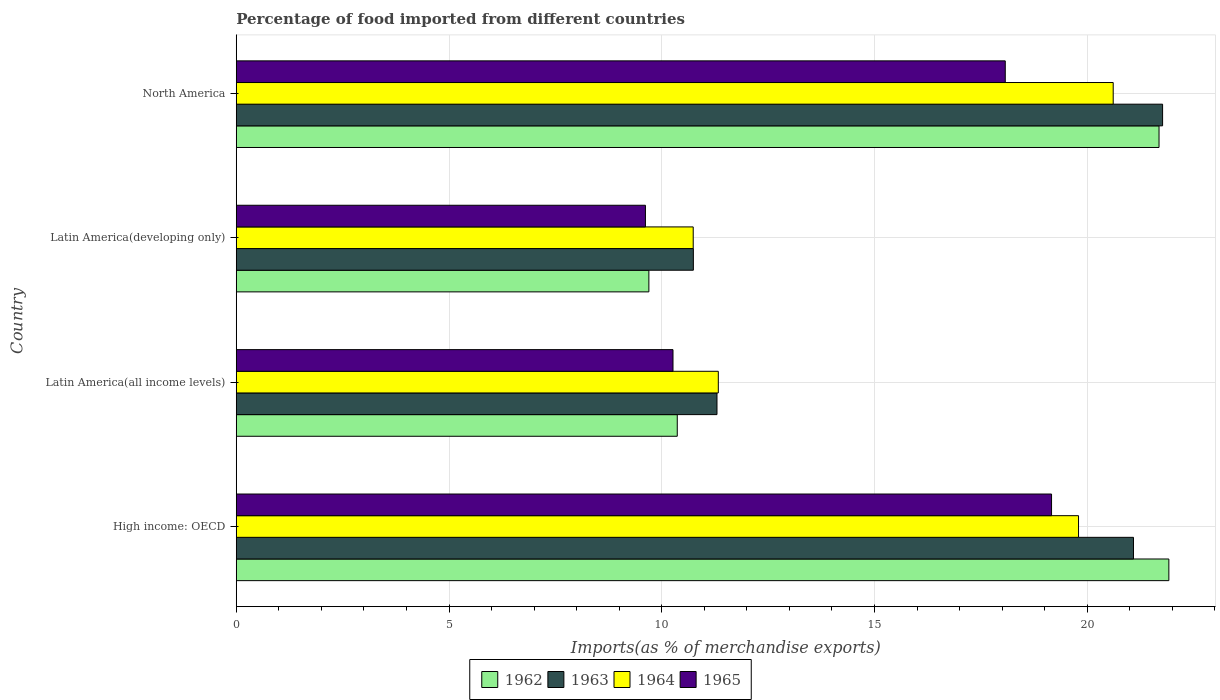What is the label of the 1st group of bars from the top?
Provide a succinct answer. North America. What is the percentage of imports to different countries in 1963 in North America?
Give a very brief answer. 21.77. Across all countries, what is the maximum percentage of imports to different countries in 1962?
Keep it short and to the point. 21.92. Across all countries, what is the minimum percentage of imports to different countries in 1962?
Provide a succinct answer. 9.7. In which country was the percentage of imports to different countries in 1962 maximum?
Your answer should be compact. High income: OECD. In which country was the percentage of imports to different countries in 1963 minimum?
Your answer should be compact. Latin America(developing only). What is the total percentage of imports to different countries in 1964 in the graph?
Provide a succinct answer. 62.47. What is the difference between the percentage of imports to different countries in 1963 in High income: OECD and that in Latin America(developing only)?
Your response must be concise. 10.34. What is the difference between the percentage of imports to different countries in 1962 in Latin America(all income levels) and the percentage of imports to different countries in 1963 in North America?
Give a very brief answer. -11.41. What is the average percentage of imports to different countries in 1965 per country?
Keep it short and to the point. 14.28. What is the difference between the percentage of imports to different countries in 1964 and percentage of imports to different countries in 1965 in Latin America(all income levels)?
Make the answer very short. 1.07. What is the ratio of the percentage of imports to different countries in 1962 in High income: OECD to that in Latin America(all income levels)?
Your answer should be compact. 2.11. Is the percentage of imports to different countries in 1965 in Latin America(all income levels) less than that in North America?
Make the answer very short. Yes. Is the difference between the percentage of imports to different countries in 1964 in High income: OECD and Latin America(developing only) greater than the difference between the percentage of imports to different countries in 1965 in High income: OECD and Latin America(developing only)?
Give a very brief answer. No. What is the difference between the highest and the second highest percentage of imports to different countries in 1963?
Make the answer very short. 0.68. What is the difference between the highest and the lowest percentage of imports to different countries in 1962?
Your answer should be compact. 12.22. Is the sum of the percentage of imports to different countries in 1962 in Latin America(all income levels) and Latin America(developing only) greater than the maximum percentage of imports to different countries in 1965 across all countries?
Ensure brevity in your answer.  Yes. What does the 4th bar from the top in Latin America(developing only) represents?
Make the answer very short. 1962. Is it the case that in every country, the sum of the percentage of imports to different countries in 1963 and percentage of imports to different countries in 1962 is greater than the percentage of imports to different countries in 1965?
Ensure brevity in your answer.  Yes. How many countries are there in the graph?
Offer a very short reply. 4. What is the difference between two consecutive major ticks on the X-axis?
Make the answer very short. 5. Does the graph contain grids?
Your response must be concise. Yes. Where does the legend appear in the graph?
Offer a terse response. Bottom center. How are the legend labels stacked?
Provide a succinct answer. Horizontal. What is the title of the graph?
Your response must be concise. Percentage of food imported from different countries. Does "2003" appear as one of the legend labels in the graph?
Ensure brevity in your answer.  No. What is the label or title of the X-axis?
Your answer should be compact. Imports(as % of merchandise exports). What is the Imports(as % of merchandise exports) of 1962 in High income: OECD?
Your answer should be very brief. 21.92. What is the Imports(as % of merchandise exports) in 1963 in High income: OECD?
Ensure brevity in your answer.  21.09. What is the Imports(as % of merchandise exports) of 1964 in High income: OECD?
Keep it short and to the point. 19.8. What is the Imports(as % of merchandise exports) of 1965 in High income: OECD?
Provide a succinct answer. 19.16. What is the Imports(as % of merchandise exports) of 1962 in Latin America(all income levels)?
Give a very brief answer. 10.36. What is the Imports(as % of merchandise exports) in 1963 in Latin America(all income levels)?
Your answer should be very brief. 11.3. What is the Imports(as % of merchandise exports) of 1964 in Latin America(all income levels)?
Provide a short and direct response. 11.33. What is the Imports(as % of merchandise exports) of 1965 in Latin America(all income levels)?
Provide a succinct answer. 10.26. What is the Imports(as % of merchandise exports) of 1962 in Latin America(developing only)?
Your response must be concise. 9.7. What is the Imports(as % of merchandise exports) in 1963 in Latin America(developing only)?
Keep it short and to the point. 10.74. What is the Imports(as % of merchandise exports) of 1964 in Latin America(developing only)?
Provide a succinct answer. 10.74. What is the Imports(as % of merchandise exports) in 1965 in Latin America(developing only)?
Ensure brevity in your answer.  9.62. What is the Imports(as % of merchandise exports) of 1962 in North America?
Ensure brevity in your answer.  21.69. What is the Imports(as % of merchandise exports) in 1963 in North America?
Your answer should be very brief. 21.77. What is the Imports(as % of merchandise exports) of 1964 in North America?
Offer a terse response. 20.61. What is the Imports(as % of merchandise exports) of 1965 in North America?
Offer a terse response. 18.07. Across all countries, what is the maximum Imports(as % of merchandise exports) of 1962?
Provide a succinct answer. 21.92. Across all countries, what is the maximum Imports(as % of merchandise exports) of 1963?
Offer a terse response. 21.77. Across all countries, what is the maximum Imports(as % of merchandise exports) in 1964?
Your answer should be very brief. 20.61. Across all countries, what is the maximum Imports(as % of merchandise exports) of 1965?
Keep it short and to the point. 19.16. Across all countries, what is the minimum Imports(as % of merchandise exports) in 1962?
Make the answer very short. 9.7. Across all countries, what is the minimum Imports(as % of merchandise exports) in 1963?
Offer a terse response. 10.74. Across all countries, what is the minimum Imports(as % of merchandise exports) of 1964?
Make the answer very short. 10.74. Across all countries, what is the minimum Imports(as % of merchandise exports) in 1965?
Your response must be concise. 9.62. What is the total Imports(as % of merchandise exports) of 1962 in the graph?
Give a very brief answer. 63.67. What is the total Imports(as % of merchandise exports) of 1963 in the graph?
Offer a very short reply. 64.9. What is the total Imports(as % of merchandise exports) in 1964 in the graph?
Your answer should be compact. 62.48. What is the total Imports(as % of merchandise exports) in 1965 in the graph?
Ensure brevity in your answer.  57.12. What is the difference between the Imports(as % of merchandise exports) of 1962 in High income: OECD and that in Latin America(all income levels)?
Offer a very short reply. 11.55. What is the difference between the Imports(as % of merchandise exports) of 1963 in High income: OECD and that in Latin America(all income levels)?
Ensure brevity in your answer.  9.79. What is the difference between the Imports(as % of merchandise exports) in 1964 in High income: OECD and that in Latin America(all income levels)?
Your answer should be very brief. 8.47. What is the difference between the Imports(as % of merchandise exports) of 1965 in High income: OECD and that in Latin America(all income levels)?
Your answer should be very brief. 8.9. What is the difference between the Imports(as % of merchandise exports) of 1962 in High income: OECD and that in Latin America(developing only)?
Offer a very short reply. 12.22. What is the difference between the Imports(as % of merchandise exports) of 1963 in High income: OECD and that in Latin America(developing only)?
Make the answer very short. 10.34. What is the difference between the Imports(as % of merchandise exports) in 1964 in High income: OECD and that in Latin America(developing only)?
Provide a short and direct response. 9.06. What is the difference between the Imports(as % of merchandise exports) in 1965 in High income: OECD and that in Latin America(developing only)?
Your answer should be compact. 9.54. What is the difference between the Imports(as % of merchandise exports) of 1962 in High income: OECD and that in North America?
Provide a short and direct response. 0.23. What is the difference between the Imports(as % of merchandise exports) in 1963 in High income: OECD and that in North America?
Your answer should be compact. -0.68. What is the difference between the Imports(as % of merchandise exports) in 1964 in High income: OECD and that in North America?
Keep it short and to the point. -0.81. What is the difference between the Imports(as % of merchandise exports) of 1965 in High income: OECD and that in North America?
Offer a terse response. 1.09. What is the difference between the Imports(as % of merchandise exports) of 1962 in Latin America(all income levels) and that in Latin America(developing only)?
Offer a terse response. 0.67. What is the difference between the Imports(as % of merchandise exports) in 1963 in Latin America(all income levels) and that in Latin America(developing only)?
Your answer should be very brief. 0.56. What is the difference between the Imports(as % of merchandise exports) of 1964 in Latin America(all income levels) and that in Latin America(developing only)?
Give a very brief answer. 0.59. What is the difference between the Imports(as % of merchandise exports) in 1965 in Latin America(all income levels) and that in Latin America(developing only)?
Ensure brevity in your answer.  0.65. What is the difference between the Imports(as % of merchandise exports) in 1962 in Latin America(all income levels) and that in North America?
Your answer should be very brief. -11.32. What is the difference between the Imports(as % of merchandise exports) in 1963 in Latin America(all income levels) and that in North America?
Your response must be concise. -10.47. What is the difference between the Imports(as % of merchandise exports) in 1964 in Latin America(all income levels) and that in North America?
Give a very brief answer. -9.28. What is the difference between the Imports(as % of merchandise exports) of 1965 in Latin America(all income levels) and that in North America?
Your answer should be compact. -7.81. What is the difference between the Imports(as % of merchandise exports) in 1962 in Latin America(developing only) and that in North America?
Provide a short and direct response. -11.99. What is the difference between the Imports(as % of merchandise exports) of 1963 in Latin America(developing only) and that in North America?
Provide a succinct answer. -11.03. What is the difference between the Imports(as % of merchandise exports) of 1964 in Latin America(developing only) and that in North America?
Your response must be concise. -9.87. What is the difference between the Imports(as % of merchandise exports) in 1965 in Latin America(developing only) and that in North America?
Make the answer very short. -8.46. What is the difference between the Imports(as % of merchandise exports) of 1962 in High income: OECD and the Imports(as % of merchandise exports) of 1963 in Latin America(all income levels)?
Provide a short and direct response. 10.62. What is the difference between the Imports(as % of merchandise exports) of 1962 in High income: OECD and the Imports(as % of merchandise exports) of 1964 in Latin America(all income levels)?
Your answer should be compact. 10.59. What is the difference between the Imports(as % of merchandise exports) of 1962 in High income: OECD and the Imports(as % of merchandise exports) of 1965 in Latin America(all income levels)?
Offer a very short reply. 11.65. What is the difference between the Imports(as % of merchandise exports) in 1963 in High income: OECD and the Imports(as % of merchandise exports) in 1964 in Latin America(all income levels)?
Offer a very short reply. 9.76. What is the difference between the Imports(as % of merchandise exports) in 1963 in High income: OECD and the Imports(as % of merchandise exports) in 1965 in Latin America(all income levels)?
Provide a short and direct response. 10.82. What is the difference between the Imports(as % of merchandise exports) of 1964 in High income: OECD and the Imports(as % of merchandise exports) of 1965 in Latin America(all income levels)?
Your answer should be very brief. 9.53. What is the difference between the Imports(as % of merchandise exports) in 1962 in High income: OECD and the Imports(as % of merchandise exports) in 1963 in Latin America(developing only)?
Your answer should be very brief. 11.18. What is the difference between the Imports(as % of merchandise exports) in 1962 in High income: OECD and the Imports(as % of merchandise exports) in 1964 in Latin America(developing only)?
Offer a terse response. 11.18. What is the difference between the Imports(as % of merchandise exports) in 1962 in High income: OECD and the Imports(as % of merchandise exports) in 1965 in Latin America(developing only)?
Keep it short and to the point. 12.3. What is the difference between the Imports(as % of merchandise exports) of 1963 in High income: OECD and the Imports(as % of merchandise exports) of 1964 in Latin America(developing only)?
Provide a short and direct response. 10.35. What is the difference between the Imports(as % of merchandise exports) of 1963 in High income: OECD and the Imports(as % of merchandise exports) of 1965 in Latin America(developing only)?
Your response must be concise. 11.47. What is the difference between the Imports(as % of merchandise exports) in 1964 in High income: OECD and the Imports(as % of merchandise exports) in 1965 in Latin America(developing only)?
Give a very brief answer. 10.18. What is the difference between the Imports(as % of merchandise exports) in 1962 in High income: OECD and the Imports(as % of merchandise exports) in 1963 in North America?
Offer a very short reply. 0.15. What is the difference between the Imports(as % of merchandise exports) in 1962 in High income: OECD and the Imports(as % of merchandise exports) in 1964 in North America?
Ensure brevity in your answer.  1.31. What is the difference between the Imports(as % of merchandise exports) of 1962 in High income: OECD and the Imports(as % of merchandise exports) of 1965 in North America?
Offer a terse response. 3.84. What is the difference between the Imports(as % of merchandise exports) of 1963 in High income: OECD and the Imports(as % of merchandise exports) of 1964 in North America?
Your answer should be very brief. 0.48. What is the difference between the Imports(as % of merchandise exports) in 1963 in High income: OECD and the Imports(as % of merchandise exports) in 1965 in North America?
Your answer should be compact. 3.01. What is the difference between the Imports(as % of merchandise exports) in 1964 in High income: OECD and the Imports(as % of merchandise exports) in 1965 in North America?
Provide a short and direct response. 1.72. What is the difference between the Imports(as % of merchandise exports) of 1962 in Latin America(all income levels) and the Imports(as % of merchandise exports) of 1963 in Latin America(developing only)?
Your answer should be compact. -0.38. What is the difference between the Imports(as % of merchandise exports) of 1962 in Latin America(all income levels) and the Imports(as % of merchandise exports) of 1964 in Latin America(developing only)?
Offer a very short reply. -0.37. What is the difference between the Imports(as % of merchandise exports) in 1962 in Latin America(all income levels) and the Imports(as % of merchandise exports) in 1965 in Latin America(developing only)?
Provide a short and direct response. 0.75. What is the difference between the Imports(as % of merchandise exports) of 1963 in Latin America(all income levels) and the Imports(as % of merchandise exports) of 1964 in Latin America(developing only)?
Provide a succinct answer. 0.56. What is the difference between the Imports(as % of merchandise exports) of 1963 in Latin America(all income levels) and the Imports(as % of merchandise exports) of 1965 in Latin America(developing only)?
Keep it short and to the point. 1.68. What is the difference between the Imports(as % of merchandise exports) of 1964 in Latin America(all income levels) and the Imports(as % of merchandise exports) of 1965 in Latin America(developing only)?
Your answer should be very brief. 1.71. What is the difference between the Imports(as % of merchandise exports) in 1962 in Latin America(all income levels) and the Imports(as % of merchandise exports) in 1963 in North America?
Your response must be concise. -11.41. What is the difference between the Imports(as % of merchandise exports) of 1962 in Latin America(all income levels) and the Imports(as % of merchandise exports) of 1964 in North America?
Offer a terse response. -10.25. What is the difference between the Imports(as % of merchandise exports) in 1962 in Latin America(all income levels) and the Imports(as % of merchandise exports) in 1965 in North America?
Offer a terse response. -7.71. What is the difference between the Imports(as % of merchandise exports) of 1963 in Latin America(all income levels) and the Imports(as % of merchandise exports) of 1964 in North America?
Provide a succinct answer. -9.31. What is the difference between the Imports(as % of merchandise exports) in 1963 in Latin America(all income levels) and the Imports(as % of merchandise exports) in 1965 in North America?
Provide a short and direct response. -6.78. What is the difference between the Imports(as % of merchandise exports) of 1964 in Latin America(all income levels) and the Imports(as % of merchandise exports) of 1965 in North America?
Your answer should be compact. -6.74. What is the difference between the Imports(as % of merchandise exports) in 1962 in Latin America(developing only) and the Imports(as % of merchandise exports) in 1963 in North America?
Offer a very short reply. -12.07. What is the difference between the Imports(as % of merchandise exports) of 1962 in Latin America(developing only) and the Imports(as % of merchandise exports) of 1964 in North America?
Offer a very short reply. -10.91. What is the difference between the Imports(as % of merchandise exports) of 1962 in Latin America(developing only) and the Imports(as % of merchandise exports) of 1965 in North America?
Your answer should be compact. -8.38. What is the difference between the Imports(as % of merchandise exports) in 1963 in Latin America(developing only) and the Imports(as % of merchandise exports) in 1964 in North America?
Provide a short and direct response. -9.87. What is the difference between the Imports(as % of merchandise exports) in 1963 in Latin America(developing only) and the Imports(as % of merchandise exports) in 1965 in North America?
Make the answer very short. -7.33. What is the difference between the Imports(as % of merchandise exports) of 1964 in Latin America(developing only) and the Imports(as % of merchandise exports) of 1965 in North America?
Your response must be concise. -7.33. What is the average Imports(as % of merchandise exports) of 1962 per country?
Keep it short and to the point. 15.92. What is the average Imports(as % of merchandise exports) in 1963 per country?
Provide a short and direct response. 16.22. What is the average Imports(as % of merchandise exports) in 1964 per country?
Ensure brevity in your answer.  15.62. What is the average Imports(as % of merchandise exports) of 1965 per country?
Keep it short and to the point. 14.28. What is the difference between the Imports(as % of merchandise exports) of 1962 and Imports(as % of merchandise exports) of 1963 in High income: OECD?
Give a very brief answer. 0.83. What is the difference between the Imports(as % of merchandise exports) of 1962 and Imports(as % of merchandise exports) of 1964 in High income: OECD?
Keep it short and to the point. 2.12. What is the difference between the Imports(as % of merchandise exports) in 1962 and Imports(as % of merchandise exports) in 1965 in High income: OECD?
Your response must be concise. 2.76. What is the difference between the Imports(as % of merchandise exports) of 1963 and Imports(as % of merchandise exports) of 1964 in High income: OECD?
Your response must be concise. 1.29. What is the difference between the Imports(as % of merchandise exports) of 1963 and Imports(as % of merchandise exports) of 1965 in High income: OECD?
Keep it short and to the point. 1.93. What is the difference between the Imports(as % of merchandise exports) in 1964 and Imports(as % of merchandise exports) in 1965 in High income: OECD?
Make the answer very short. 0.63. What is the difference between the Imports(as % of merchandise exports) in 1962 and Imports(as % of merchandise exports) in 1963 in Latin America(all income levels)?
Offer a very short reply. -0.93. What is the difference between the Imports(as % of merchandise exports) of 1962 and Imports(as % of merchandise exports) of 1964 in Latin America(all income levels)?
Ensure brevity in your answer.  -0.96. What is the difference between the Imports(as % of merchandise exports) of 1962 and Imports(as % of merchandise exports) of 1965 in Latin America(all income levels)?
Provide a succinct answer. 0.1. What is the difference between the Imports(as % of merchandise exports) of 1963 and Imports(as % of merchandise exports) of 1964 in Latin America(all income levels)?
Ensure brevity in your answer.  -0.03. What is the difference between the Imports(as % of merchandise exports) of 1963 and Imports(as % of merchandise exports) of 1965 in Latin America(all income levels)?
Your answer should be compact. 1.03. What is the difference between the Imports(as % of merchandise exports) of 1964 and Imports(as % of merchandise exports) of 1965 in Latin America(all income levels)?
Offer a terse response. 1.07. What is the difference between the Imports(as % of merchandise exports) in 1962 and Imports(as % of merchandise exports) in 1963 in Latin America(developing only)?
Make the answer very short. -1.05. What is the difference between the Imports(as % of merchandise exports) in 1962 and Imports(as % of merchandise exports) in 1964 in Latin America(developing only)?
Your answer should be very brief. -1.04. What is the difference between the Imports(as % of merchandise exports) of 1962 and Imports(as % of merchandise exports) of 1965 in Latin America(developing only)?
Ensure brevity in your answer.  0.08. What is the difference between the Imports(as % of merchandise exports) of 1963 and Imports(as % of merchandise exports) of 1964 in Latin America(developing only)?
Your answer should be compact. 0. What is the difference between the Imports(as % of merchandise exports) of 1963 and Imports(as % of merchandise exports) of 1965 in Latin America(developing only)?
Your answer should be compact. 1.13. What is the difference between the Imports(as % of merchandise exports) of 1964 and Imports(as % of merchandise exports) of 1965 in Latin America(developing only)?
Give a very brief answer. 1.12. What is the difference between the Imports(as % of merchandise exports) in 1962 and Imports(as % of merchandise exports) in 1963 in North America?
Offer a terse response. -0.08. What is the difference between the Imports(as % of merchandise exports) in 1962 and Imports(as % of merchandise exports) in 1964 in North America?
Make the answer very short. 1.08. What is the difference between the Imports(as % of merchandise exports) of 1962 and Imports(as % of merchandise exports) of 1965 in North America?
Provide a succinct answer. 3.61. What is the difference between the Imports(as % of merchandise exports) of 1963 and Imports(as % of merchandise exports) of 1964 in North America?
Offer a very short reply. 1.16. What is the difference between the Imports(as % of merchandise exports) of 1963 and Imports(as % of merchandise exports) of 1965 in North America?
Provide a short and direct response. 3.7. What is the difference between the Imports(as % of merchandise exports) of 1964 and Imports(as % of merchandise exports) of 1965 in North America?
Offer a terse response. 2.54. What is the ratio of the Imports(as % of merchandise exports) in 1962 in High income: OECD to that in Latin America(all income levels)?
Provide a short and direct response. 2.11. What is the ratio of the Imports(as % of merchandise exports) of 1963 in High income: OECD to that in Latin America(all income levels)?
Provide a short and direct response. 1.87. What is the ratio of the Imports(as % of merchandise exports) in 1964 in High income: OECD to that in Latin America(all income levels)?
Your response must be concise. 1.75. What is the ratio of the Imports(as % of merchandise exports) in 1965 in High income: OECD to that in Latin America(all income levels)?
Ensure brevity in your answer.  1.87. What is the ratio of the Imports(as % of merchandise exports) in 1962 in High income: OECD to that in Latin America(developing only)?
Provide a succinct answer. 2.26. What is the ratio of the Imports(as % of merchandise exports) of 1963 in High income: OECD to that in Latin America(developing only)?
Provide a short and direct response. 1.96. What is the ratio of the Imports(as % of merchandise exports) in 1964 in High income: OECD to that in Latin America(developing only)?
Your answer should be compact. 1.84. What is the ratio of the Imports(as % of merchandise exports) of 1965 in High income: OECD to that in Latin America(developing only)?
Your answer should be very brief. 1.99. What is the ratio of the Imports(as % of merchandise exports) in 1962 in High income: OECD to that in North America?
Give a very brief answer. 1.01. What is the ratio of the Imports(as % of merchandise exports) of 1963 in High income: OECD to that in North America?
Make the answer very short. 0.97. What is the ratio of the Imports(as % of merchandise exports) of 1964 in High income: OECD to that in North America?
Your response must be concise. 0.96. What is the ratio of the Imports(as % of merchandise exports) in 1965 in High income: OECD to that in North America?
Give a very brief answer. 1.06. What is the ratio of the Imports(as % of merchandise exports) in 1962 in Latin America(all income levels) to that in Latin America(developing only)?
Provide a succinct answer. 1.07. What is the ratio of the Imports(as % of merchandise exports) of 1963 in Latin America(all income levels) to that in Latin America(developing only)?
Provide a short and direct response. 1.05. What is the ratio of the Imports(as % of merchandise exports) of 1964 in Latin America(all income levels) to that in Latin America(developing only)?
Keep it short and to the point. 1.05. What is the ratio of the Imports(as % of merchandise exports) in 1965 in Latin America(all income levels) to that in Latin America(developing only)?
Provide a succinct answer. 1.07. What is the ratio of the Imports(as % of merchandise exports) in 1962 in Latin America(all income levels) to that in North America?
Provide a succinct answer. 0.48. What is the ratio of the Imports(as % of merchandise exports) of 1963 in Latin America(all income levels) to that in North America?
Provide a succinct answer. 0.52. What is the ratio of the Imports(as % of merchandise exports) in 1964 in Latin America(all income levels) to that in North America?
Offer a terse response. 0.55. What is the ratio of the Imports(as % of merchandise exports) of 1965 in Latin America(all income levels) to that in North America?
Provide a succinct answer. 0.57. What is the ratio of the Imports(as % of merchandise exports) of 1962 in Latin America(developing only) to that in North America?
Ensure brevity in your answer.  0.45. What is the ratio of the Imports(as % of merchandise exports) in 1963 in Latin America(developing only) to that in North America?
Provide a succinct answer. 0.49. What is the ratio of the Imports(as % of merchandise exports) in 1964 in Latin America(developing only) to that in North America?
Your response must be concise. 0.52. What is the ratio of the Imports(as % of merchandise exports) of 1965 in Latin America(developing only) to that in North America?
Offer a terse response. 0.53. What is the difference between the highest and the second highest Imports(as % of merchandise exports) in 1962?
Offer a terse response. 0.23. What is the difference between the highest and the second highest Imports(as % of merchandise exports) in 1963?
Your response must be concise. 0.68. What is the difference between the highest and the second highest Imports(as % of merchandise exports) of 1964?
Provide a short and direct response. 0.81. What is the difference between the highest and the second highest Imports(as % of merchandise exports) of 1965?
Your answer should be compact. 1.09. What is the difference between the highest and the lowest Imports(as % of merchandise exports) in 1962?
Your answer should be very brief. 12.22. What is the difference between the highest and the lowest Imports(as % of merchandise exports) in 1963?
Make the answer very short. 11.03. What is the difference between the highest and the lowest Imports(as % of merchandise exports) in 1964?
Make the answer very short. 9.87. What is the difference between the highest and the lowest Imports(as % of merchandise exports) of 1965?
Your response must be concise. 9.54. 